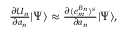<formula> <loc_0><loc_0><loc_500><loc_500>\begin{array} { r } { \frac { \partial U _ { n } } { \partial a _ { n } } | \Psi \rangle \approx \frac { \partial ( e _ { m } ^ { B _ { n } } ) ^ { s } } { \partial a _ { n } } | \Psi \rangle , } \end{array}</formula> 